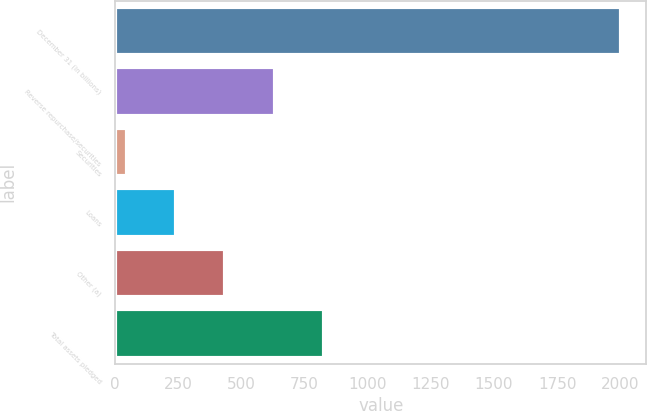Convert chart. <chart><loc_0><loc_0><loc_500><loc_500><bar_chart><fcel>December 31 (in billions)<fcel>Reverse repurchase/securities<fcel>Securities<fcel>Loans<fcel>Other (a)<fcel>Total assets pledged<nl><fcel>2003<fcel>632.4<fcel>45<fcel>240.8<fcel>436.6<fcel>828.2<nl></chart> 